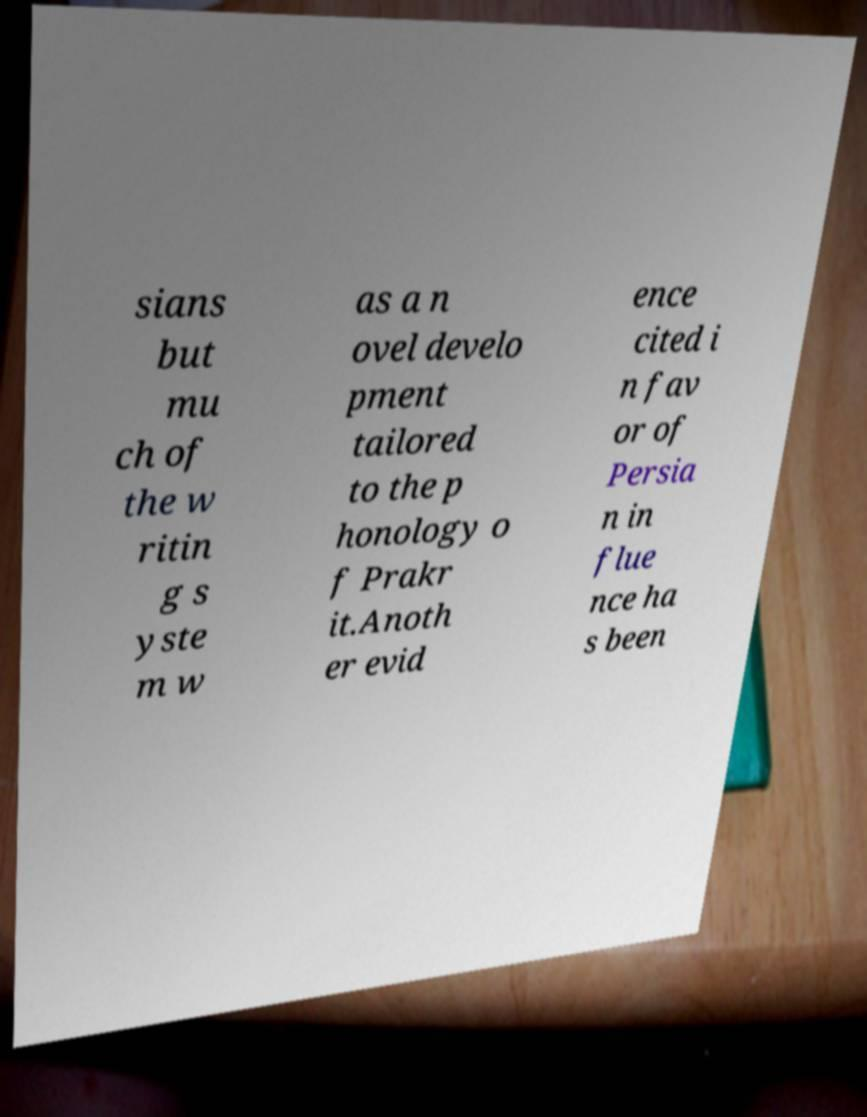Could you assist in decoding the text presented in this image and type it out clearly? sians but mu ch of the w ritin g s yste m w as a n ovel develo pment tailored to the p honology o f Prakr it.Anoth er evid ence cited i n fav or of Persia n in flue nce ha s been 